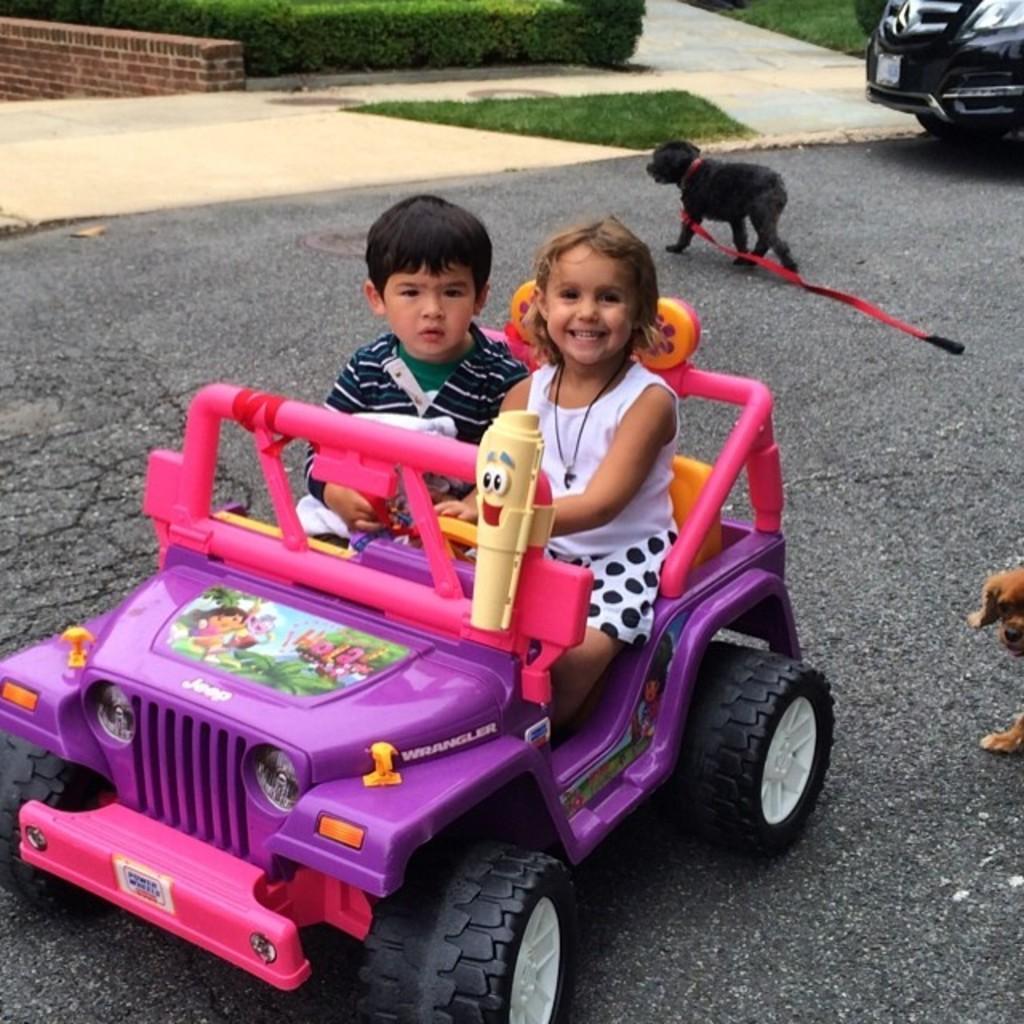In one or two sentences, can you explain what this image depicts? In this picture we can see two kids playing with the toy. This is road and there is a dog. Here we can see some plants. And this is grass. 